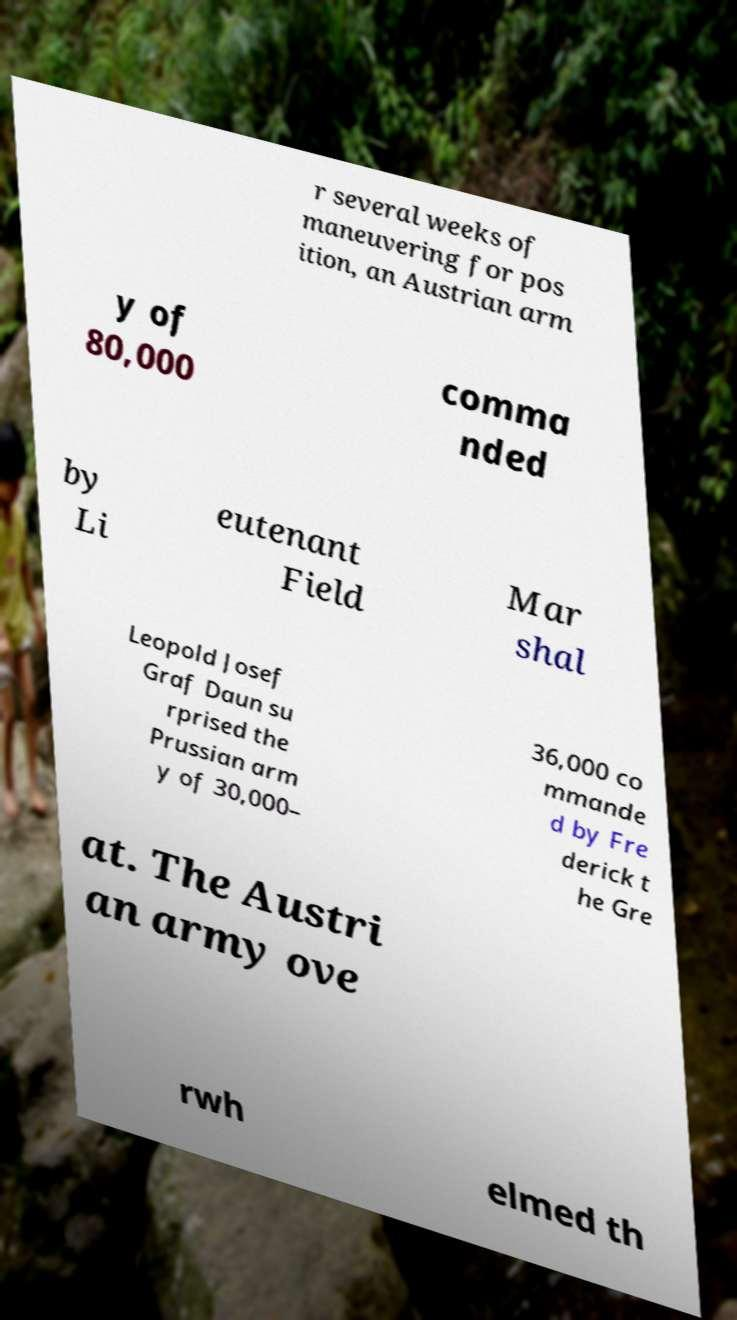Please identify and transcribe the text found in this image. r several weeks of maneuvering for pos ition, an Austrian arm y of 80,000 comma nded by Li eutenant Field Mar shal Leopold Josef Graf Daun su rprised the Prussian arm y of 30,000– 36,000 co mmande d by Fre derick t he Gre at. The Austri an army ove rwh elmed th 